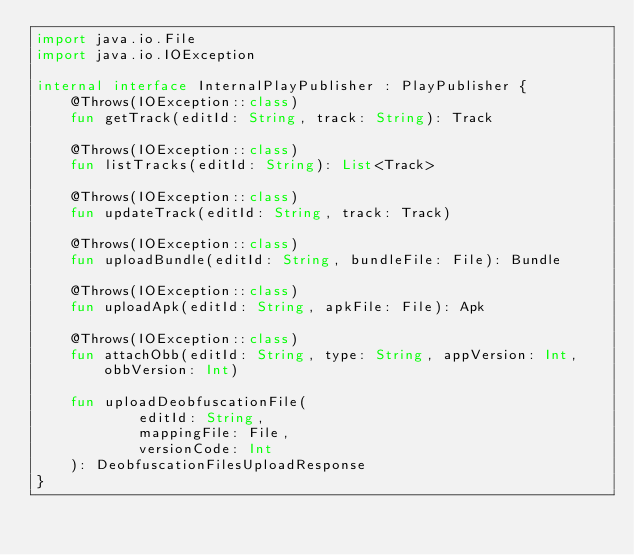Convert code to text. <code><loc_0><loc_0><loc_500><loc_500><_Kotlin_>import java.io.File
import java.io.IOException

internal interface InternalPlayPublisher : PlayPublisher {
    @Throws(IOException::class)
    fun getTrack(editId: String, track: String): Track

    @Throws(IOException::class)
    fun listTracks(editId: String): List<Track>

    @Throws(IOException::class)
    fun updateTrack(editId: String, track: Track)

    @Throws(IOException::class)
    fun uploadBundle(editId: String, bundleFile: File): Bundle

    @Throws(IOException::class)
    fun uploadApk(editId: String, apkFile: File): Apk

    @Throws(IOException::class)
    fun attachObb(editId: String, type: String, appVersion: Int, obbVersion: Int)

    fun uploadDeobfuscationFile(
            editId: String,
            mappingFile: File,
            versionCode: Int
    ): DeobfuscationFilesUploadResponse
}
</code> 